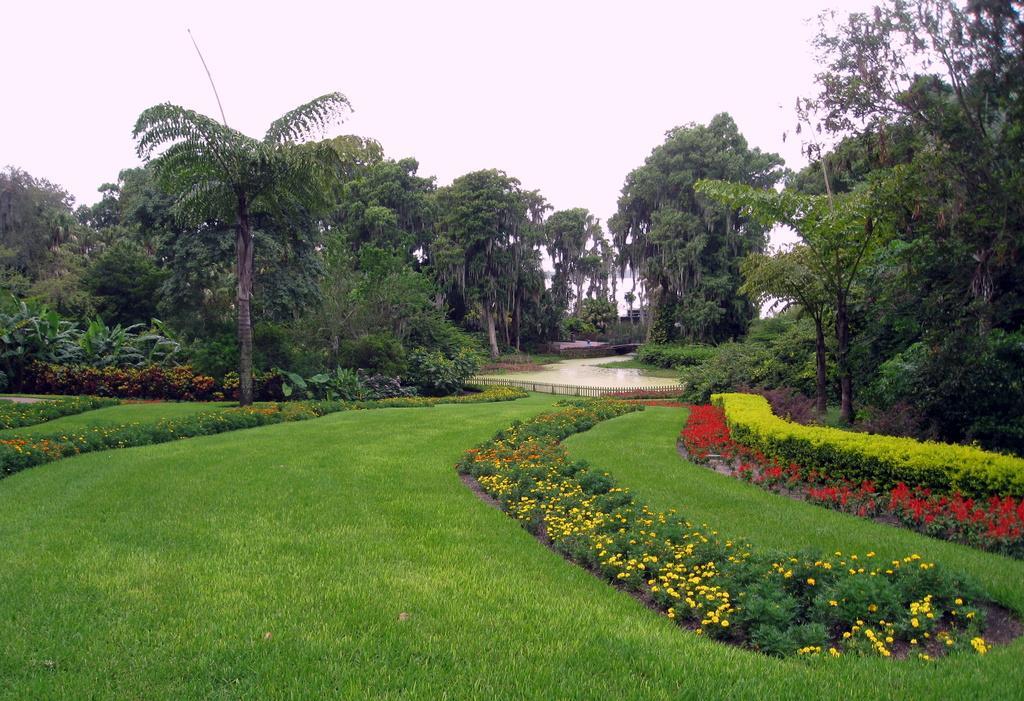How would you summarize this image in a sentence or two? In this image, we can see green grass on the ground, we can see some plants and trees, at the top there is a sky. 